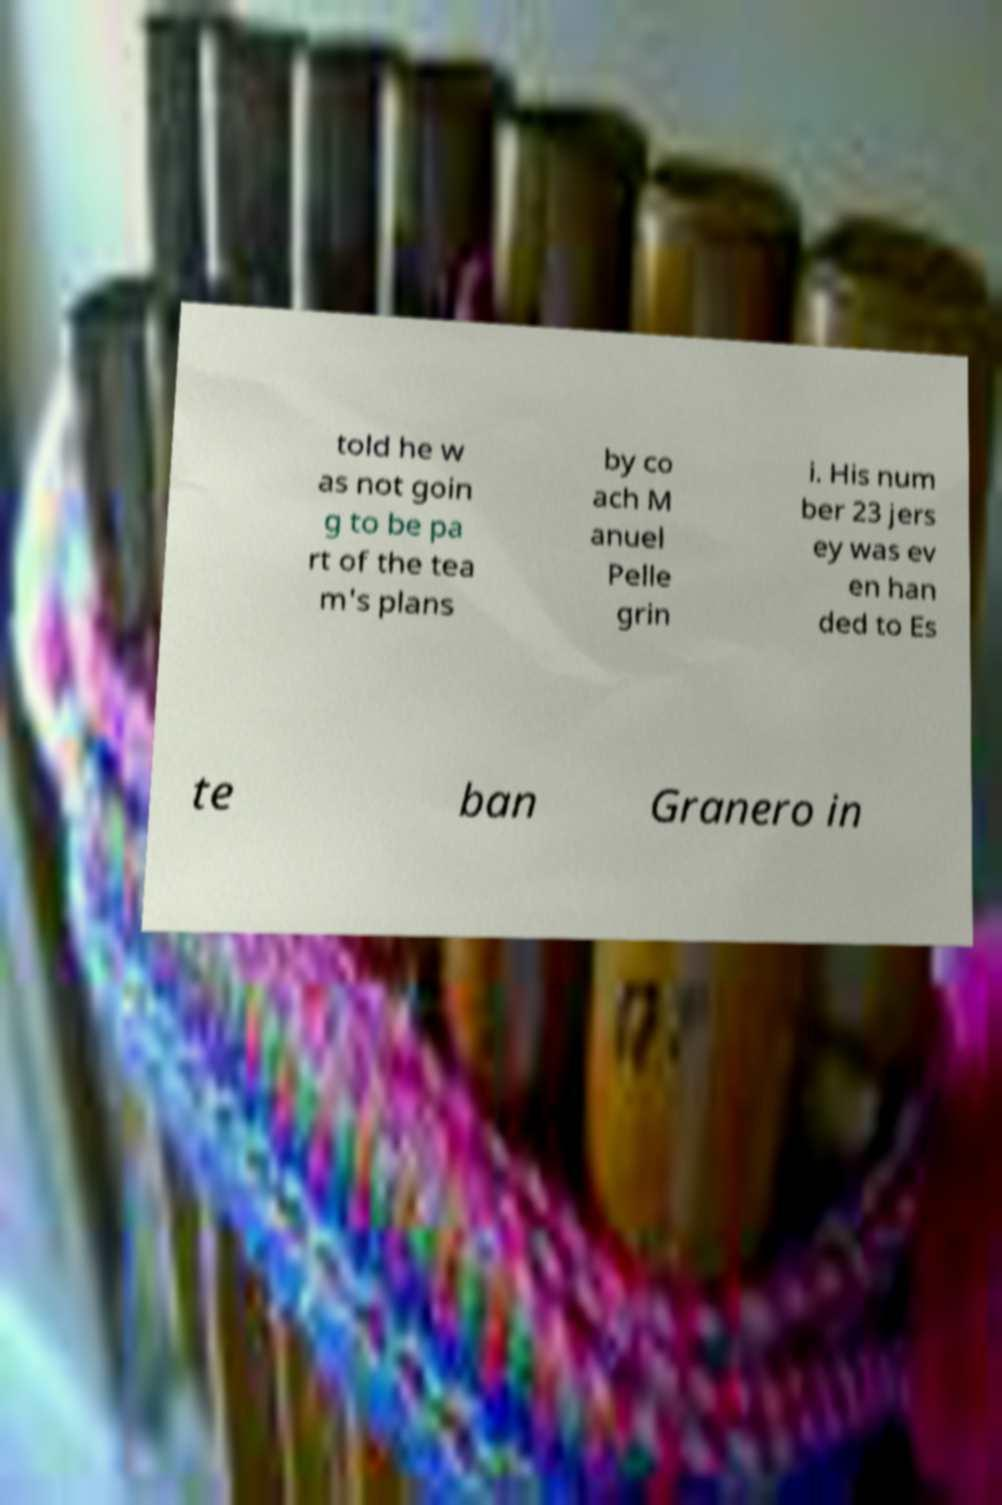Could you assist in decoding the text presented in this image and type it out clearly? told he w as not goin g to be pa rt of the tea m's plans by co ach M anuel Pelle grin i. His num ber 23 jers ey was ev en han ded to Es te ban Granero in 